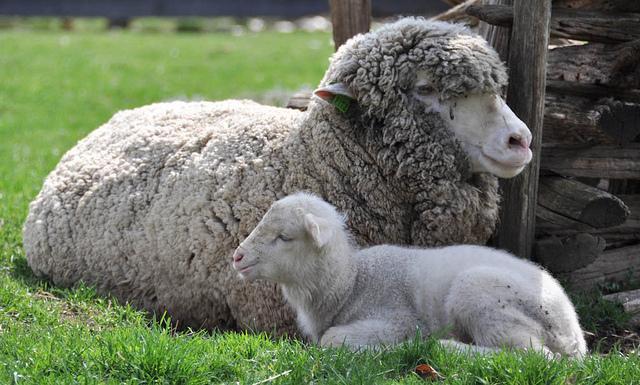How many animals are in the pic?
Give a very brief answer. 2. How many sheep are in the photo?
Give a very brief answer. 2. 